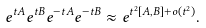<formula> <loc_0><loc_0><loc_500><loc_500>e ^ { t A } e ^ { t B } e ^ { - t A } e ^ { - t B } \approx e ^ { t ^ { 2 } [ A , B ] + o ( t ^ { 2 } ) } .</formula> 